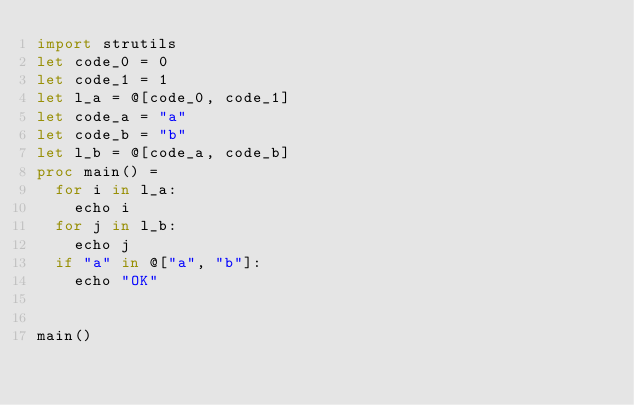<code> <loc_0><loc_0><loc_500><loc_500><_Nim_>import strutils
let code_0 = 0
let code_1 = 1
let l_a = @[code_0, code_1]
let code_a = "a"
let code_b = "b"
let l_b = @[code_a, code_b]
proc main() =
  for i in l_a:
    echo i
  for j in l_b:
    echo j
  if "a" in @["a", "b"]:
    echo "OK"


main()
</code> 